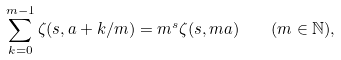<formula> <loc_0><loc_0><loc_500><loc_500>\sum ^ { m - 1 } _ { k = 0 } \zeta ( s , a + k / m ) = m ^ { s } \zeta ( s , m a ) \quad ( m \in \mathbb { N } ) ,</formula> 